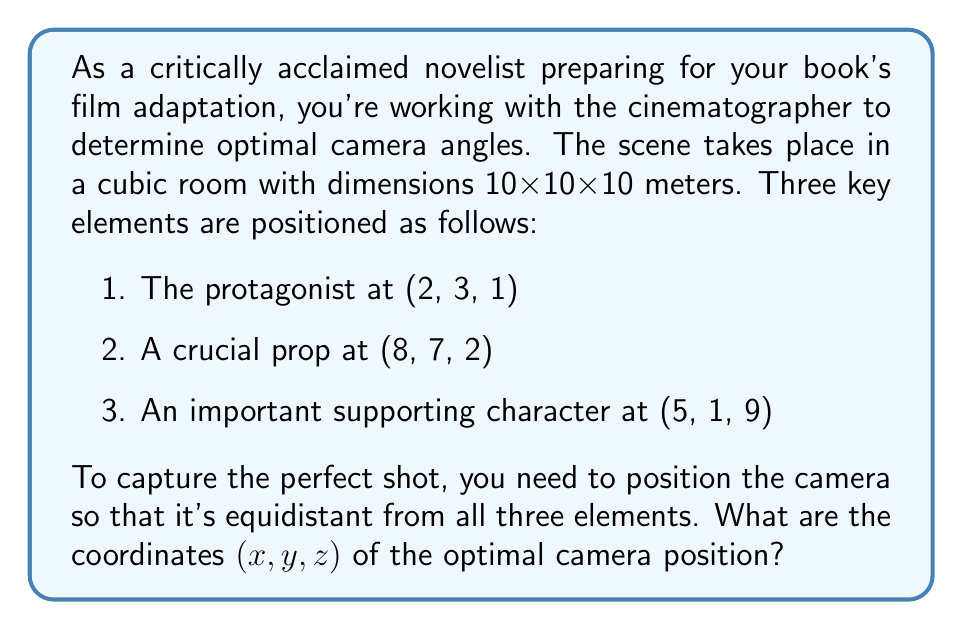Solve this math problem. To solve this problem, we need to find a point that is equidistant from the three given points. This point is the center of a sphere that passes through all three points. We can use the following steps:

1. Let the camera position be $(x, y, z)$.

2. The distance from the camera to each point should be equal. Let's call this distance $r$. We can set up three equations:

   $$(x-2)^2 + (y-3)^2 + (z-1)^2 = r^2$$
   $$(x-8)^2 + (y-7)^2 + (z-2)^2 = r^2$$
   $$(x-5)^2 + (y-1)^2 + (z-9)^2 = r^2$$

3. Subtracting the first equation from the second and third:

   $$(x-8)^2 + (y-7)^2 + (z-2)^2 = (x-2)^2 + (y-3)^2 + (z-1)^2$$
   $$(x-5)^2 + (y-1)^2 + (z-9)^2 = (x-2)^2 + (y-3)^2 + (z-1)^2$$

4. Expanding and simplifying:

   $$x^2 - 16x + 64 + y^2 - 14y + 49 + z^2 - 4z + 4 = x^2 - 4x + 4 + y^2 - 6y + 9 + z^2 - 2z + 1$$
   $$x^2 - 10x + 25 + y^2 - 2y + 1 + z^2 - 18z + 81 = x^2 - 4x + 4 + y^2 - 6y + 9 + z^2 - 2z + 1$$

5. Cancelling out common terms:

   $$-12x - 8y - 2z = -60$$
   $$-6x + 4y - 16z = -80$$

6. Multiply the first equation by 2 and subtract from the second:

   $$-24x - 16y - 4z = -120$$
   $$-6x + 4y - 16z = -80$$
   $$18x + 20y - 12z = 40$$

7. Now we have a system of three linear equations:

   $$-12x - 8y - 2z = -60$$
   $$-6x + 4y - 16z = -80$$
   $$18x + 20y - 12z = 40$$

8. Solving this system (using substitution or matrix methods) gives:

   $$x = 5$$
   $$y = 3.5$$
   $$z = 4$$

Therefore, the optimal camera position is (5, 3.5, 4).
Answer: (5, 3.5, 4) 